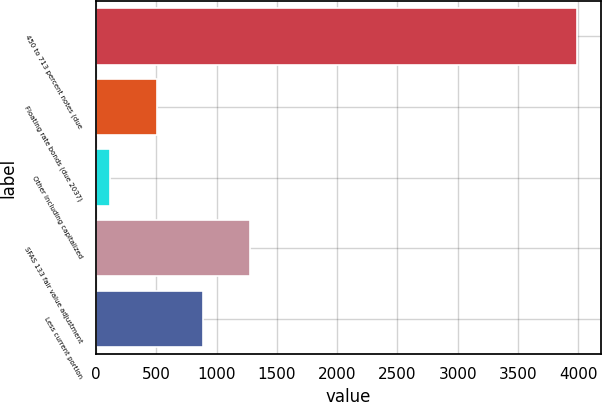Convert chart. <chart><loc_0><loc_0><loc_500><loc_500><bar_chart><fcel>450 to 713 percent notes (due<fcel>Floating rate bonds (due 2037)<fcel>Other including capitalized<fcel>SFAS 133 fair value adjustment<fcel>Less current portion<nl><fcel>3987.4<fcel>503.86<fcel>116.8<fcel>1277.98<fcel>890.92<nl></chart> 